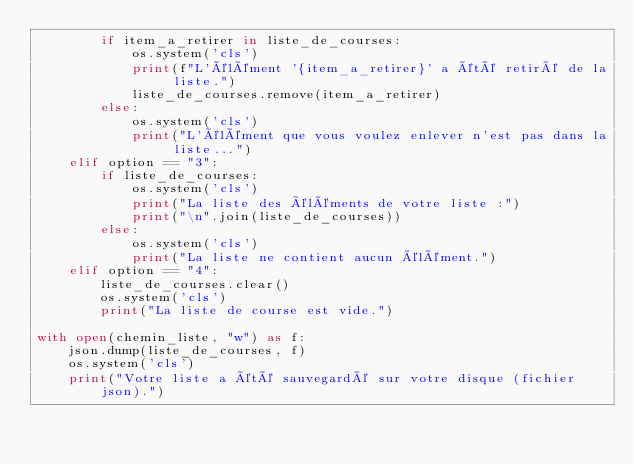Convert code to text. <code><loc_0><loc_0><loc_500><loc_500><_Python_>        if item_a_retirer in liste_de_courses:
            os.system('cls')
            print(f"L'élément '{item_a_retirer}' a été retiré de la liste.")
            liste_de_courses.remove(item_a_retirer)
        else:
            os.system('cls')
            print("L'élément que vous voulez enlever n'est pas dans la liste...")
    elif option == "3":
        if liste_de_courses: 
            os.system('cls')
            print("La liste des éléments de votre liste :")
            print("\n".join(liste_de_courses))
        else:
            os.system('cls')
            print("La liste ne contient aucun élément.")    
    elif option == "4":
        liste_de_courses.clear()
        os.system('cls') 
        print("La liste de course est vide.")     

with open(chemin_liste, "w") as f:
    json.dump(liste_de_courses, f)
    os.system('cls') 
    print("Votre liste a été sauvegardé sur votre disque (fichier json).")</code> 